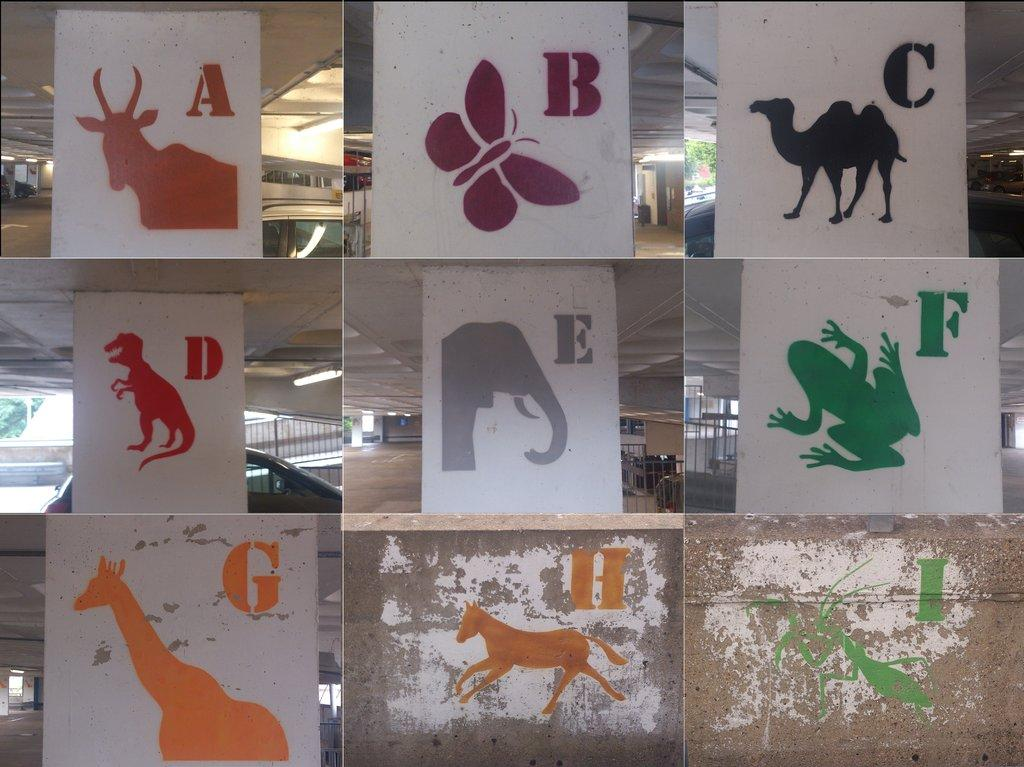What type of artwork is the image? The image is a collage. What architectural elements can be seen in the collage? There are pillars in the image. What is depicted on the pillars? Images and alphabets are present on the pillars. What type of transportation is visible in the image? Vehicles are visible in the image. What type of illumination is present in the image? Lights are present in the image. What structural elements can be seen in the image? Rods are present in the image. Where is the volleyball court located in the image? There is no volleyball court present in the image. What type of bottle is visible on the pillar in the image? There is no bottle present on the pillar or in the image. 